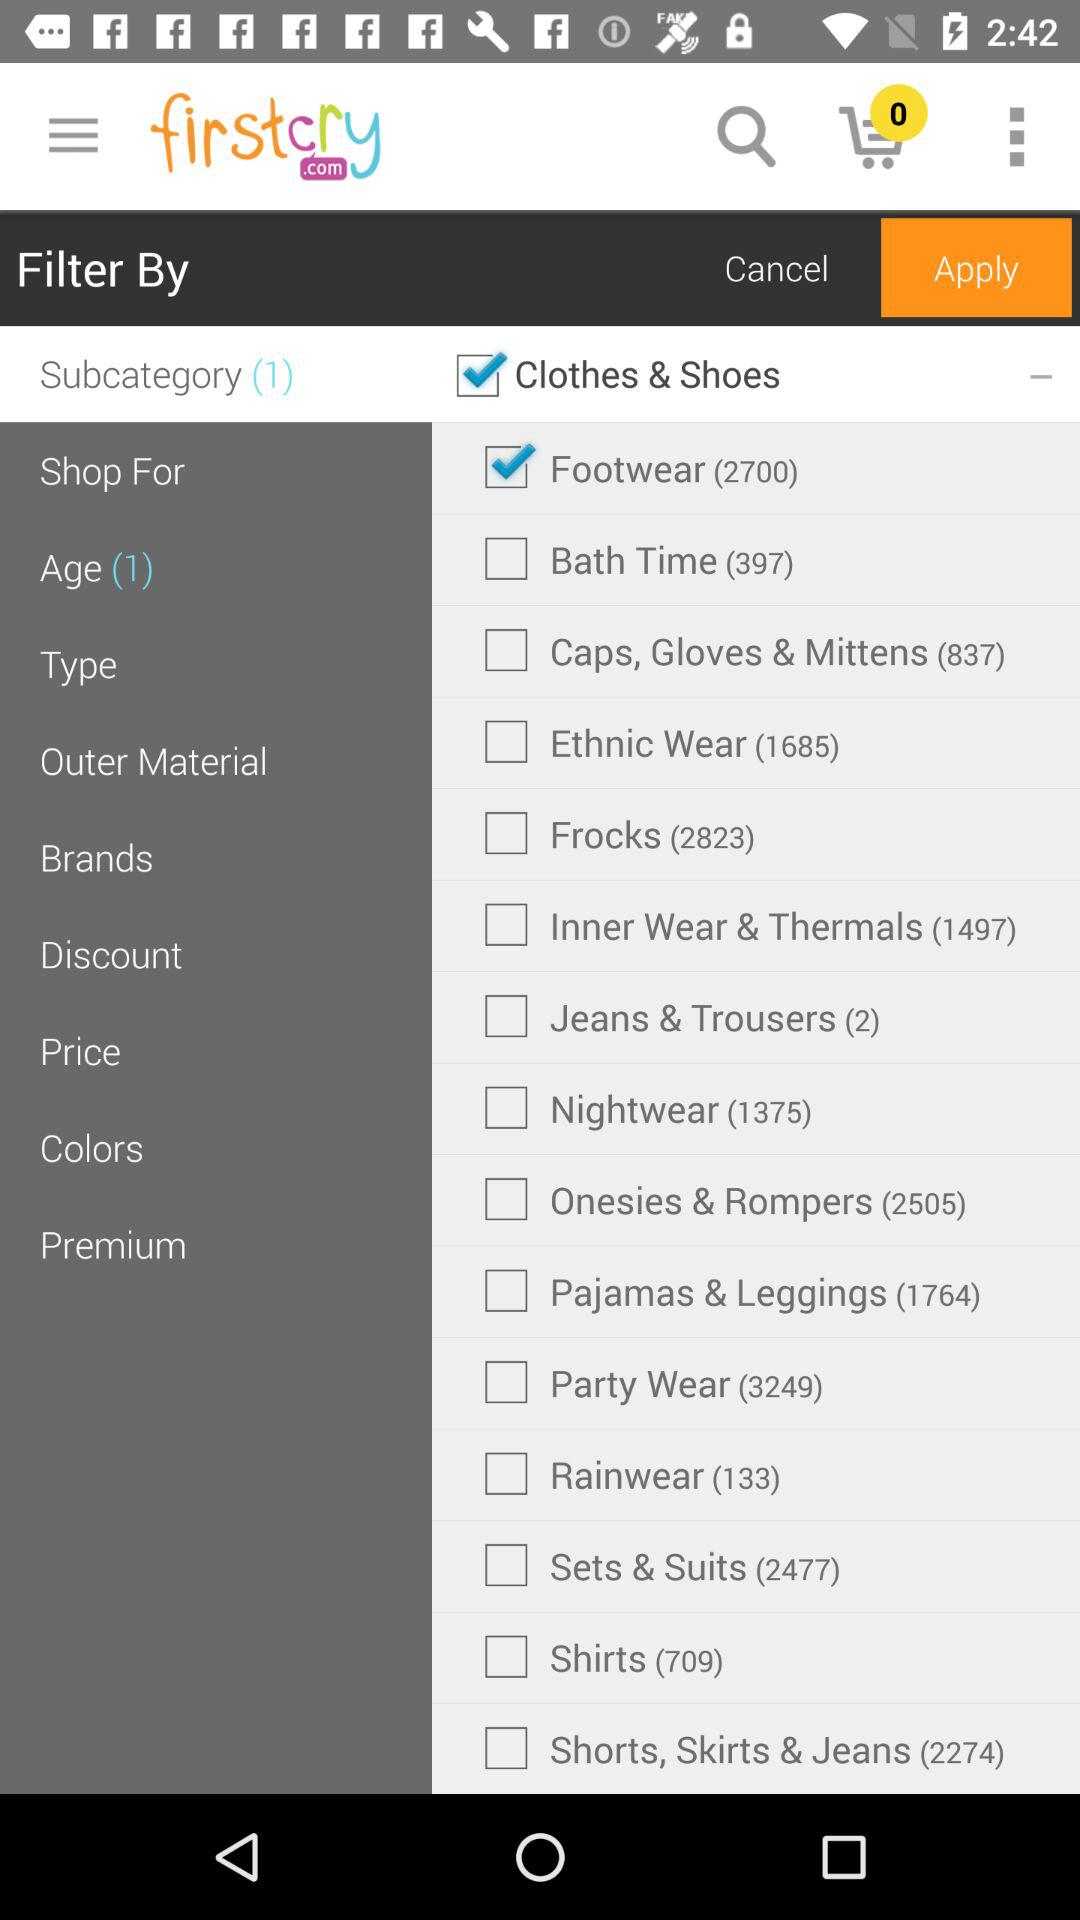How many rainwears are there? There are 133 rainwears. 